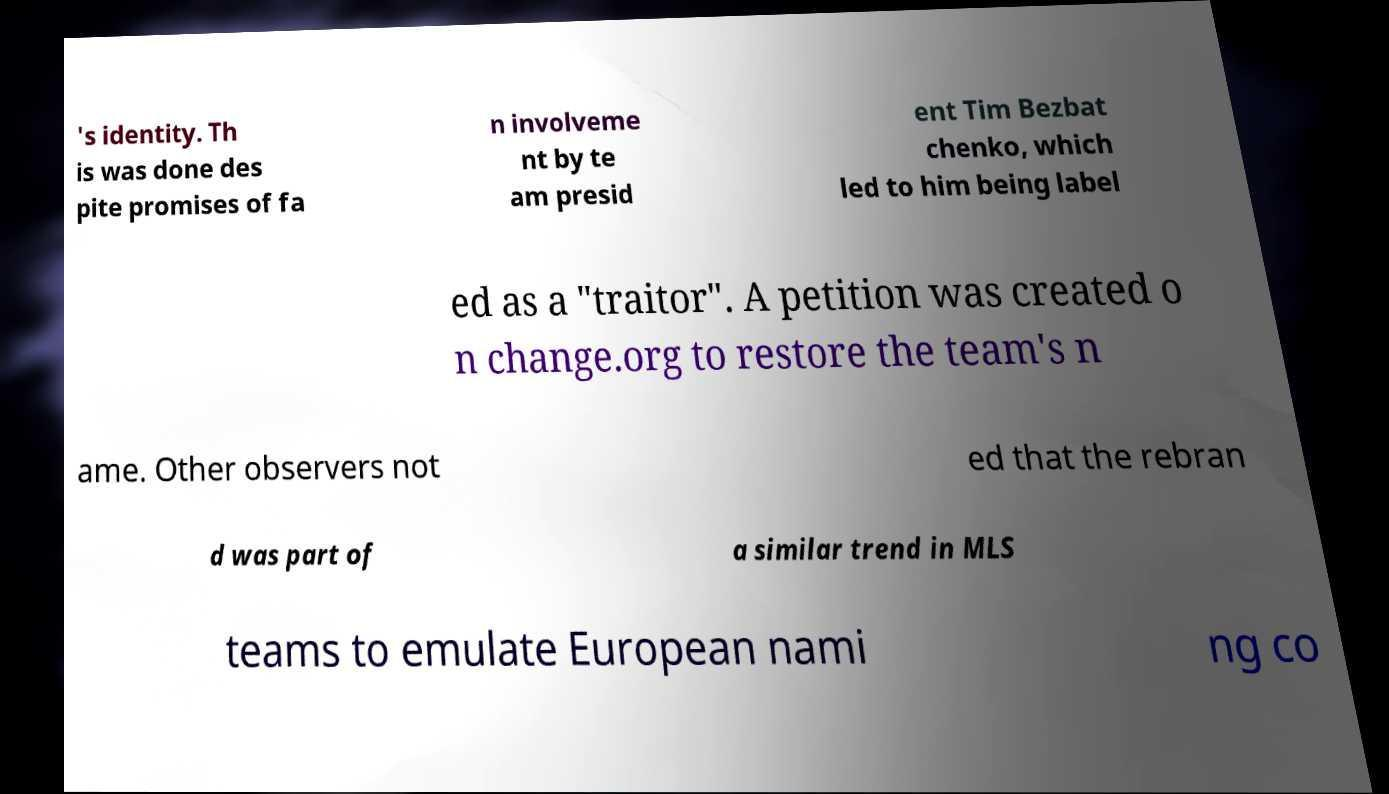I need the written content from this picture converted into text. Can you do that? 's identity. Th is was done des pite promises of fa n involveme nt by te am presid ent Tim Bezbat chenko, which led to him being label ed as a "traitor". A petition was created o n change.org to restore the team's n ame. Other observers not ed that the rebran d was part of a similar trend in MLS teams to emulate European nami ng co 